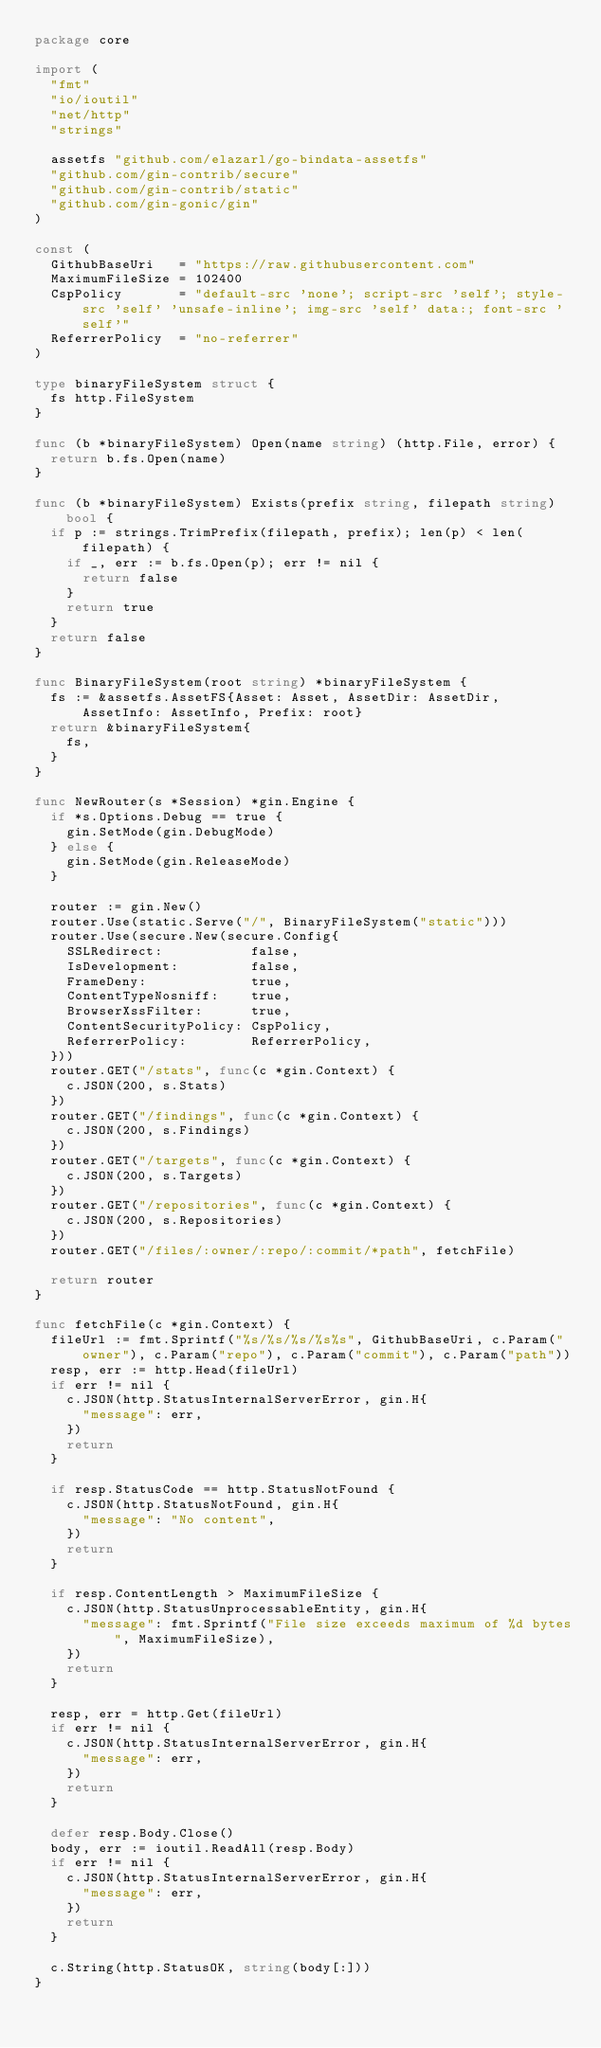<code> <loc_0><loc_0><loc_500><loc_500><_Go_>package core

import (
  "fmt"
  "io/ioutil"
  "net/http"
  "strings"

  assetfs "github.com/elazarl/go-bindata-assetfs"
  "github.com/gin-contrib/secure"
  "github.com/gin-contrib/static"
  "github.com/gin-gonic/gin"
)

const (
  GithubBaseUri   = "https://raw.githubusercontent.com"
  MaximumFileSize = 102400
  CspPolicy       = "default-src 'none'; script-src 'self'; style-src 'self' 'unsafe-inline'; img-src 'self' data:; font-src 'self'"
  ReferrerPolicy  = "no-referrer"
)

type binaryFileSystem struct {
  fs http.FileSystem
}

func (b *binaryFileSystem) Open(name string) (http.File, error) {
  return b.fs.Open(name)
}

func (b *binaryFileSystem) Exists(prefix string, filepath string) bool {
  if p := strings.TrimPrefix(filepath, prefix); len(p) < len(filepath) {
    if _, err := b.fs.Open(p); err != nil {
      return false
    }
    return true
  }
  return false
}

func BinaryFileSystem(root string) *binaryFileSystem {
  fs := &assetfs.AssetFS{Asset: Asset, AssetDir: AssetDir, AssetInfo: AssetInfo, Prefix: root}
  return &binaryFileSystem{
    fs,
  }
}

func NewRouter(s *Session) *gin.Engine {
  if *s.Options.Debug == true {
    gin.SetMode(gin.DebugMode)
  } else {
    gin.SetMode(gin.ReleaseMode)
  }

  router := gin.New()
  router.Use(static.Serve("/", BinaryFileSystem("static")))
  router.Use(secure.New(secure.Config{
    SSLRedirect:           false,
    IsDevelopment:         false,
    FrameDeny:             true,
    ContentTypeNosniff:    true,
    BrowserXssFilter:      true,
    ContentSecurityPolicy: CspPolicy,
    ReferrerPolicy:        ReferrerPolicy,
  }))
  router.GET("/stats", func(c *gin.Context) {
    c.JSON(200, s.Stats)
  })
  router.GET("/findings", func(c *gin.Context) {
    c.JSON(200, s.Findings)
  })
  router.GET("/targets", func(c *gin.Context) {
    c.JSON(200, s.Targets)
  })
  router.GET("/repositories", func(c *gin.Context) {
    c.JSON(200, s.Repositories)
  })
  router.GET("/files/:owner/:repo/:commit/*path", fetchFile)

  return router
}

func fetchFile(c *gin.Context) {
  fileUrl := fmt.Sprintf("%s/%s/%s/%s%s", GithubBaseUri, c.Param("owner"), c.Param("repo"), c.Param("commit"), c.Param("path"))
  resp, err := http.Head(fileUrl)
  if err != nil {
    c.JSON(http.StatusInternalServerError, gin.H{
      "message": err,
    })
    return
  }

  if resp.StatusCode == http.StatusNotFound {
    c.JSON(http.StatusNotFound, gin.H{
      "message": "No content",
    })
    return
  }

  if resp.ContentLength > MaximumFileSize {
    c.JSON(http.StatusUnprocessableEntity, gin.H{
      "message": fmt.Sprintf("File size exceeds maximum of %d bytes", MaximumFileSize),
    })
    return
  }

  resp, err = http.Get(fileUrl)
  if err != nil {
    c.JSON(http.StatusInternalServerError, gin.H{
      "message": err,
    })
    return
  }

  defer resp.Body.Close()
  body, err := ioutil.ReadAll(resp.Body)
  if err != nil {
    c.JSON(http.StatusInternalServerError, gin.H{
      "message": err,
    })
    return
  }

  c.String(http.StatusOK, string(body[:]))
}
</code> 